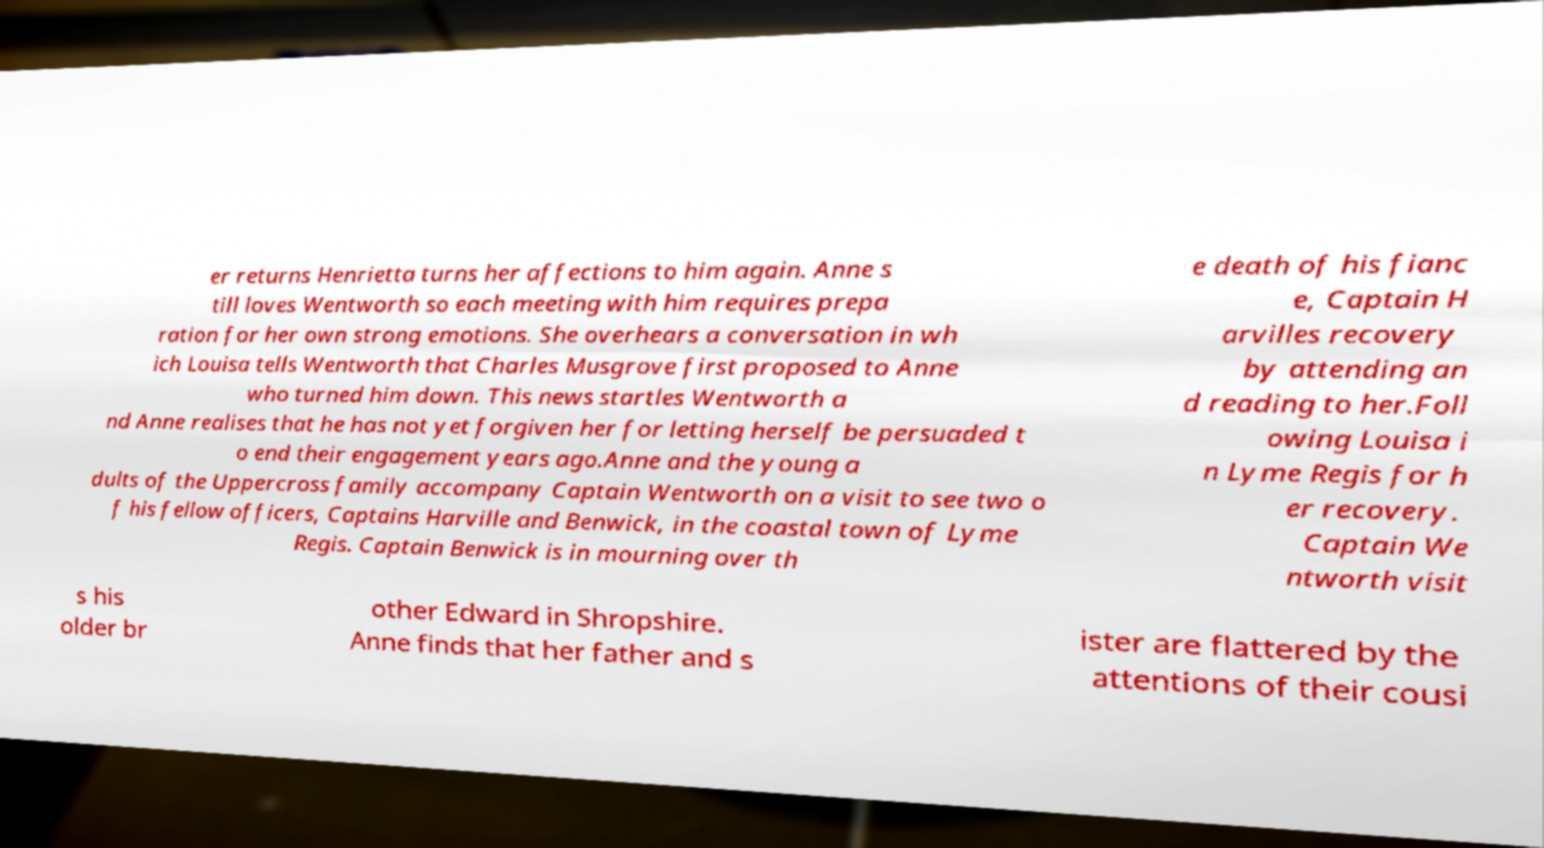There's text embedded in this image that I need extracted. Can you transcribe it verbatim? er returns Henrietta turns her affections to him again. Anne s till loves Wentworth so each meeting with him requires prepa ration for her own strong emotions. She overhears a conversation in wh ich Louisa tells Wentworth that Charles Musgrove first proposed to Anne who turned him down. This news startles Wentworth a nd Anne realises that he has not yet forgiven her for letting herself be persuaded t o end their engagement years ago.Anne and the young a dults of the Uppercross family accompany Captain Wentworth on a visit to see two o f his fellow officers, Captains Harville and Benwick, in the coastal town of Lyme Regis. Captain Benwick is in mourning over th e death of his fianc e, Captain H arvilles recovery by attending an d reading to her.Foll owing Louisa i n Lyme Regis for h er recovery. Captain We ntworth visit s his older br other Edward in Shropshire. Anne finds that her father and s ister are flattered by the attentions of their cousi 